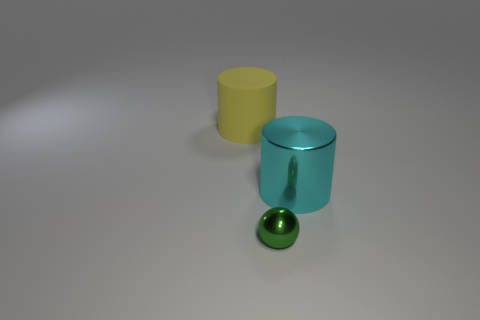Subtract all yellow spheres. Subtract all brown cubes. How many spheres are left? 1 Add 3 big yellow matte objects. How many objects exist? 6 Subtract all cylinders. How many objects are left? 1 Subtract 0 brown blocks. How many objects are left? 3 Subtract all shiny things. Subtract all brown metal cubes. How many objects are left? 1 Add 3 spheres. How many spheres are left? 4 Add 3 small brown matte blocks. How many small brown matte blocks exist? 3 